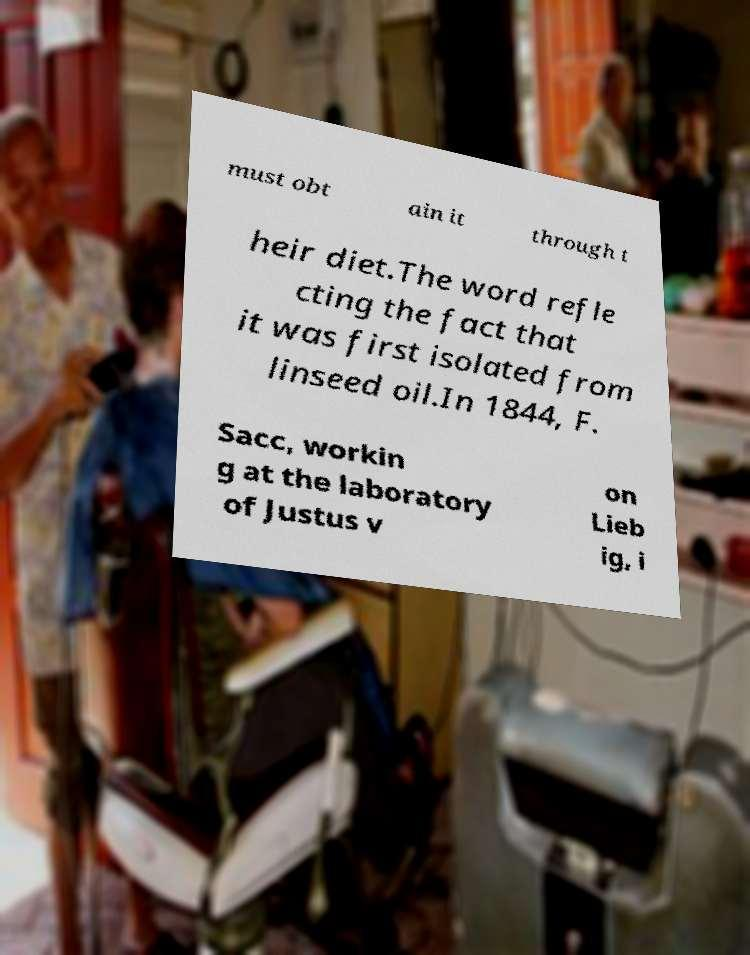For documentation purposes, I need the text within this image transcribed. Could you provide that? must obt ain it through t heir diet.The word refle cting the fact that it was first isolated from linseed oil.In 1844, F. Sacc, workin g at the laboratory of Justus v on Lieb ig, i 